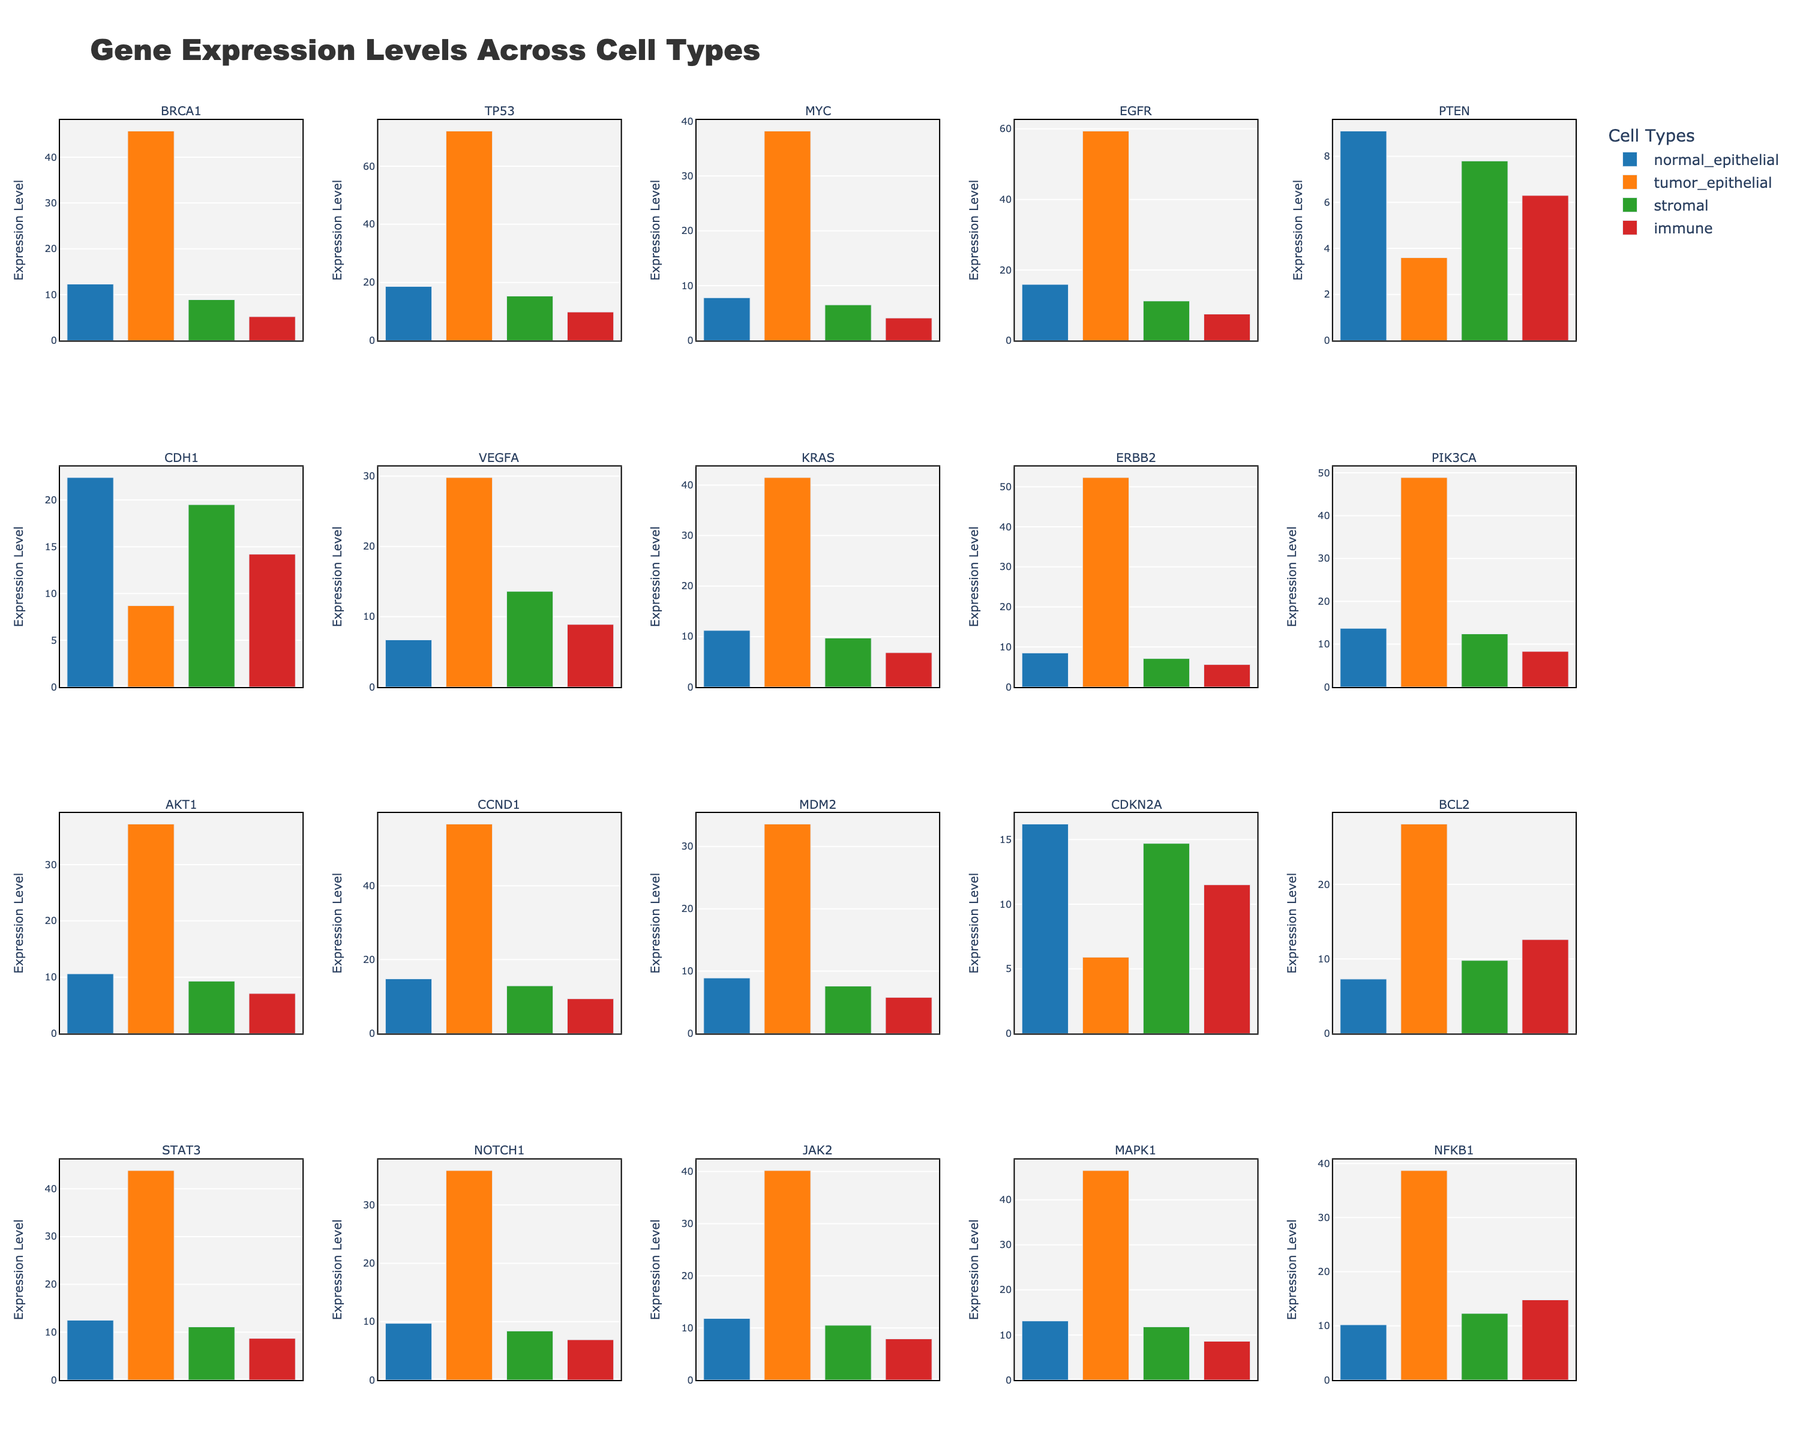Which gene has the highest expression level in tumor epithelial cells? To find this, locate the bar associated with tumor epithelial cells for all genes and identify the tallest bar. The tallest bar represents the highest expression level.
Answer: TP53 Which gene shows the smallest difference in expression between normal epithelial and tumor epithelial cells? Calculate the difference between normal epithelial and tumor epithelial cells for all genes. Identify the gene with the smallest numerical difference.
Answer: PTEN What is the average expression level of BRCA1 across all cell types? Add the expression levels of BRCA1 for all cell types and divide the sum by the number of cell types (4). BRCA1 levels: 12.3 (normal) + 45.7 (tumor) + 8.9 (stromal) + 5.2 (immune) = 72.1. The average is 72.1 / 4 = 18.025.
Answer: 18.025 Which gene has a higher expression level in stromal cells than in normal epithelial cells? Compare the expression levels of each gene in stromal cells and normal epithelial cells. Identify the gene(s) where the stromal cell expression is greater.
Answer: CDH1 What is the total expression level for KRAS across all cell types? Sum the expression levels of KRAS in all cell types: 11.2 (normal) + 41.5 (tumor) + 9.7 (stromal) + 6.8 (immune) = 69.2.
Answer: 69.2 Which cell type has the most uniform expression levels across different genes? Compare the range of expression levels (difference between the maximum and minimum) across genes for each cell type. The cell type with the smallest range has the most uniform expression levels.
Answer: Immune What is the difference in average expression levels between STAT3 and NOTCH1 across all cell types? Find the average expression level for STAT3 and NOTCH1. STAT3: (12.5 + 43.8 + 11.1 + 8.7)/4 = 19.025. NOTCH1: (9.7 + 35.9 + 8.4 + 6.9)/4 = 15.225. The difference is 19.025 - 15.225 = 3.8.
Answer: 3.8 Which gene has the highest expression level in immune cells? Identify the tallest bar in the immune cells category for all genes.
Answer: NFKB1 